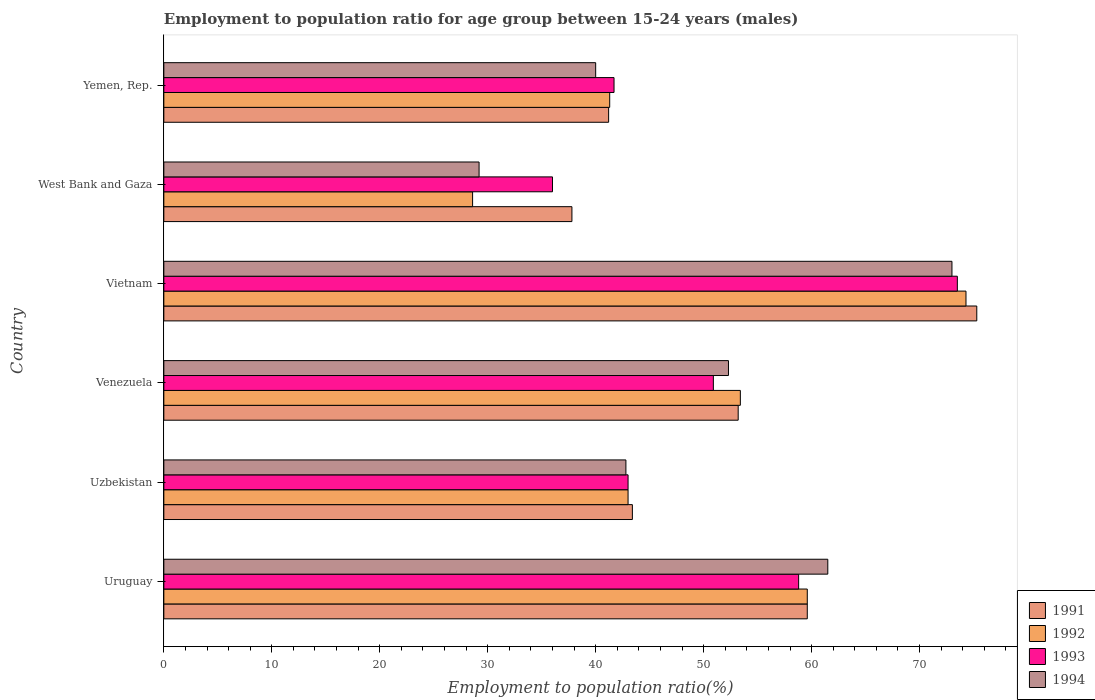How many bars are there on the 2nd tick from the top?
Your answer should be very brief. 4. What is the label of the 5th group of bars from the top?
Offer a very short reply. Uzbekistan. In how many cases, is the number of bars for a given country not equal to the number of legend labels?
Ensure brevity in your answer.  0. What is the employment to population ratio in 1993 in Uruguay?
Offer a very short reply. 58.8. Across all countries, what is the maximum employment to population ratio in 1991?
Ensure brevity in your answer.  75.3. Across all countries, what is the minimum employment to population ratio in 1994?
Give a very brief answer. 29.2. In which country was the employment to population ratio in 1992 maximum?
Provide a succinct answer. Vietnam. In which country was the employment to population ratio in 1994 minimum?
Make the answer very short. West Bank and Gaza. What is the total employment to population ratio in 1994 in the graph?
Make the answer very short. 298.8. What is the difference between the employment to population ratio in 1992 in Uruguay and that in Uzbekistan?
Your answer should be compact. 16.6. What is the difference between the employment to population ratio in 1993 in Venezuela and the employment to population ratio in 1994 in Uruguay?
Give a very brief answer. -10.6. What is the average employment to population ratio in 1994 per country?
Your answer should be compact. 49.8. What is the difference between the employment to population ratio in 1993 and employment to population ratio in 1991 in Uzbekistan?
Give a very brief answer. -0.4. What is the ratio of the employment to population ratio in 1993 in Uruguay to that in Venezuela?
Provide a short and direct response. 1.16. Is the employment to population ratio in 1991 in Uruguay less than that in Venezuela?
Offer a very short reply. No. Is the difference between the employment to population ratio in 1993 in Uruguay and West Bank and Gaza greater than the difference between the employment to population ratio in 1991 in Uruguay and West Bank and Gaza?
Offer a terse response. Yes. What is the difference between the highest and the second highest employment to population ratio in 1993?
Ensure brevity in your answer.  14.7. What is the difference between the highest and the lowest employment to population ratio in 1994?
Make the answer very short. 43.8. Is it the case that in every country, the sum of the employment to population ratio in 1993 and employment to population ratio in 1992 is greater than the sum of employment to population ratio in 1991 and employment to population ratio in 1994?
Offer a very short reply. No. What does the 1st bar from the bottom in Vietnam represents?
Provide a succinct answer. 1991. Are all the bars in the graph horizontal?
Offer a very short reply. Yes. What is the difference between two consecutive major ticks on the X-axis?
Provide a succinct answer. 10. How are the legend labels stacked?
Provide a short and direct response. Vertical. What is the title of the graph?
Provide a short and direct response. Employment to population ratio for age group between 15-24 years (males). Does "1985" appear as one of the legend labels in the graph?
Provide a succinct answer. No. What is the label or title of the X-axis?
Give a very brief answer. Employment to population ratio(%). What is the label or title of the Y-axis?
Provide a succinct answer. Country. What is the Employment to population ratio(%) of 1991 in Uruguay?
Provide a short and direct response. 59.6. What is the Employment to population ratio(%) of 1992 in Uruguay?
Ensure brevity in your answer.  59.6. What is the Employment to population ratio(%) of 1993 in Uruguay?
Offer a terse response. 58.8. What is the Employment to population ratio(%) in 1994 in Uruguay?
Offer a terse response. 61.5. What is the Employment to population ratio(%) in 1991 in Uzbekistan?
Offer a very short reply. 43.4. What is the Employment to population ratio(%) in 1993 in Uzbekistan?
Offer a very short reply. 43. What is the Employment to population ratio(%) of 1994 in Uzbekistan?
Your answer should be compact. 42.8. What is the Employment to population ratio(%) in 1991 in Venezuela?
Provide a short and direct response. 53.2. What is the Employment to population ratio(%) in 1992 in Venezuela?
Your answer should be compact. 53.4. What is the Employment to population ratio(%) in 1993 in Venezuela?
Your answer should be very brief. 50.9. What is the Employment to population ratio(%) of 1994 in Venezuela?
Your answer should be very brief. 52.3. What is the Employment to population ratio(%) in 1991 in Vietnam?
Your response must be concise. 75.3. What is the Employment to population ratio(%) of 1992 in Vietnam?
Your answer should be compact. 74.3. What is the Employment to population ratio(%) of 1993 in Vietnam?
Offer a very short reply. 73.5. What is the Employment to population ratio(%) in 1994 in Vietnam?
Keep it short and to the point. 73. What is the Employment to population ratio(%) of 1991 in West Bank and Gaza?
Your answer should be compact. 37.8. What is the Employment to population ratio(%) of 1992 in West Bank and Gaza?
Your answer should be very brief. 28.6. What is the Employment to population ratio(%) of 1993 in West Bank and Gaza?
Offer a terse response. 36. What is the Employment to population ratio(%) in 1994 in West Bank and Gaza?
Offer a very short reply. 29.2. What is the Employment to population ratio(%) in 1991 in Yemen, Rep.?
Your answer should be very brief. 41.2. What is the Employment to population ratio(%) in 1992 in Yemen, Rep.?
Your answer should be compact. 41.3. What is the Employment to population ratio(%) in 1993 in Yemen, Rep.?
Provide a succinct answer. 41.7. Across all countries, what is the maximum Employment to population ratio(%) of 1991?
Your response must be concise. 75.3. Across all countries, what is the maximum Employment to population ratio(%) of 1992?
Make the answer very short. 74.3. Across all countries, what is the maximum Employment to population ratio(%) of 1993?
Your answer should be very brief. 73.5. Across all countries, what is the maximum Employment to population ratio(%) of 1994?
Make the answer very short. 73. Across all countries, what is the minimum Employment to population ratio(%) of 1991?
Your answer should be very brief. 37.8. Across all countries, what is the minimum Employment to population ratio(%) of 1992?
Your answer should be compact. 28.6. Across all countries, what is the minimum Employment to population ratio(%) of 1994?
Provide a short and direct response. 29.2. What is the total Employment to population ratio(%) of 1991 in the graph?
Give a very brief answer. 310.5. What is the total Employment to population ratio(%) in 1992 in the graph?
Make the answer very short. 300.2. What is the total Employment to population ratio(%) of 1993 in the graph?
Provide a succinct answer. 303.9. What is the total Employment to population ratio(%) in 1994 in the graph?
Your answer should be compact. 298.8. What is the difference between the Employment to population ratio(%) of 1991 in Uruguay and that in Uzbekistan?
Ensure brevity in your answer.  16.2. What is the difference between the Employment to population ratio(%) in 1993 in Uruguay and that in Uzbekistan?
Offer a very short reply. 15.8. What is the difference between the Employment to population ratio(%) of 1994 in Uruguay and that in Uzbekistan?
Provide a succinct answer. 18.7. What is the difference between the Employment to population ratio(%) of 1991 in Uruguay and that in Venezuela?
Provide a succinct answer. 6.4. What is the difference between the Employment to population ratio(%) in 1992 in Uruguay and that in Venezuela?
Give a very brief answer. 6.2. What is the difference between the Employment to population ratio(%) in 1994 in Uruguay and that in Venezuela?
Provide a succinct answer. 9.2. What is the difference between the Employment to population ratio(%) of 1991 in Uruguay and that in Vietnam?
Give a very brief answer. -15.7. What is the difference between the Employment to population ratio(%) in 1992 in Uruguay and that in Vietnam?
Give a very brief answer. -14.7. What is the difference between the Employment to population ratio(%) in 1993 in Uruguay and that in Vietnam?
Your answer should be compact. -14.7. What is the difference between the Employment to population ratio(%) of 1994 in Uruguay and that in Vietnam?
Make the answer very short. -11.5. What is the difference between the Employment to population ratio(%) in 1991 in Uruguay and that in West Bank and Gaza?
Provide a short and direct response. 21.8. What is the difference between the Employment to population ratio(%) of 1992 in Uruguay and that in West Bank and Gaza?
Offer a very short reply. 31. What is the difference between the Employment to population ratio(%) in 1993 in Uruguay and that in West Bank and Gaza?
Provide a short and direct response. 22.8. What is the difference between the Employment to population ratio(%) of 1994 in Uruguay and that in West Bank and Gaza?
Your response must be concise. 32.3. What is the difference between the Employment to population ratio(%) in 1993 in Uruguay and that in Yemen, Rep.?
Offer a terse response. 17.1. What is the difference between the Employment to population ratio(%) of 1991 in Uzbekistan and that in Venezuela?
Provide a succinct answer. -9.8. What is the difference between the Employment to population ratio(%) in 1992 in Uzbekistan and that in Venezuela?
Give a very brief answer. -10.4. What is the difference between the Employment to population ratio(%) of 1991 in Uzbekistan and that in Vietnam?
Offer a terse response. -31.9. What is the difference between the Employment to population ratio(%) in 1992 in Uzbekistan and that in Vietnam?
Give a very brief answer. -31.3. What is the difference between the Employment to population ratio(%) in 1993 in Uzbekistan and that in Vietnam?
Your answer should be compact. -30.5. What is the difference between the Employment to population ratio(%) of 1994 in Uzbekistan and that in Vietnam?
Your response must be concise. -30.2. What is the difference between the Employment to population ratio(%) of 1991 in Uzbekistan and that in West Bank and Gaza?
Keep it short and to the point. 5.6. What is the difference between the Employment to population ratio(%) in 1992 in Uzbekistan and that in West Bank and Gaza?
Provide a succinct answer. 14.4. What is the difference between the Employment to population ratio(%) of 1993 in Uzbekistan and that in West Bank and Gaza?
Your answer should be compact. 7. What is the difference between the Employment to population ratio(%) in 1992 in Uzbekistan and that in Yemen, Rep.?
Your answer should be compact. 1.7. What is the difference between the Employment to population ratio(%) of 1991 in Venezuela and that in Vietnam?
Offer a terse response. -22.1. What is the difference between the Employment to population ratio(%) of 1992 in Venezuela and that in Vietnam?
Provide a short and direct response. -20.9. What is the difference between the Employment to population ratio(%) of 1993 in Venezuela and that in Vietnam?
Offer a very short reply. -22.6. What is the difference between the Employment to population ratio(%) in 1994 in Venezuela and that in Vietnam?
Keep it short and to the point. -20.7. What is the difference between the Employment to population ratio(%) of 1992 in Venezuela and that in West Bank and Gaza?
Your answer should be very brief. 24.8. What is the difference between the Employment to population ratio(%) in 1993 in Venezuela and that in West Bank and Gaza?
Provide a short and direct response. 14.9. What is the difference between the Employment to population ratio(%) in 1994 in Venezuela and that in West Bank and Gaza?
Keep it short and to the point. 23.1. What is the difference between the Employment to population ratio(%) of 1994 in Venezuela and that in Yemen, Rep.?
Offer a very short reply. 12.3. What is the difference between the Employment to population ratio(%) of 1991 in Vietnam and that in West Bank and Gaza?
Keep it short and to the point. 37.5. What is the difference between the Employment to population ratio(%) of 1992 in Vietnam and that in West Bank and Gaza?
Offer a terse response. 45.7. What is the difference between the Employment to population ratio(%) in 1993 in Vietnam and that in West Bank and Gaza?
Your answer should be very brief. 37.5. What is the difference between the Employment to population ratio(%) of 1994 in Vietnam and that in West Bank and Gaza?
Give a very brief answer. 43.8. What is the difference between the Employment to population ratio(%) in 1991 in Vietnam and that in Yemen, Rep.?
Make the answer very short. 34.1. What is the difference between the Employment to population ratio(%) of 1992 in Vietnam and that in Yemen, Rep.?
Make the answer very short. 33. What is the difference between the Employment to population ratio(%) in 1993 in Vietnam and that in Yemen, Rep.?
Keep it short and to the point. 31.8. What is the difference between the Employment to population ratio(%) of 1994 in Vietnam and that in Yemen, Rep.?
Provide a short and direct response. 33. What is the difference between the Employment to population ratio(%) of 1992 in West Bank and Gaza and that in Yemen, Rep.?
Make the answer very short. -12.7. What is the difference between the Employment to population ratio(%) of 1993 in West Bank and Gaza and that in Yemen, Rep.?
Your response must be concise. -5.7. What is the difference between the Employment to population ratio(%) in 1994 in West Bank and Gaza and that in Yemen, Rep.?
Your answer should be compact. -10.8. What is the difference between the Employment to population ratio(%) in 1991 in Uruguay and the Employment to population ratio(%) in 1992 in Uzbekistan?
Provide a short and direct response. 16.6. What is the difference between the Employment to population ratio(%) in 1991 in Uruguay and the Employment to population ratio(%) in 1993 in Uzbekistan?
Ensure brevity in your answer.  16.6. What is the difference between the Employment to population ratio(%) in 1991 in Uruguay and the Employment to population ratio(%) in 1994 in Uzbekistan?
Provide a succinct answer. 16.8. What is the difference between the Employment to population ratio(%) of 1993 in Uruguay and the Employment to population ratio(%) of 1994 in Uzbekistan?
Your answer should be very brief. 16. What is the difference between the Employment to population ratio(%) in 1991 in Uruguay and the Employment to population ratio(%) in 1992 in Venezuela?
Keep it short and to the point. 6.2. What is the difference between the Employment to population ratio(%) of 1991 in Uruguay and the Employment to population ratio(%) of 1993 in Venezuela?
Keep it short and to the point. 8.7. What is the difference between the Employment to population ratio(%) in 1991 in Uruguay and the Employment to population ratio(%) in 1994 in Venezuela?
Keep it short and to the point. 7.3. What is the difference between the Employment to population ratio(%) of 1991 in Uruguay and the Employment to population ratio(%) of 1992 in Vietnam?
Your answer should be very brief. -14.7. What is the difference between the Employment to population ratio(%) in 1991 in Uruguay and the Employment to population ratio(%) in 1993 in Vietnam?
Your answer should be compact. -13.9. What is the difference between the Employment to population ratio(%) in 1992 in Uruguay and the Employment to population ratio(%) in 1994 in Vietnam?
Ensure brevity in your answer.  -13.4. What is the difference between the Employment to population ratio(%) in 1991 in Uruguay and the Employment to population ratio(%) in 1992 in West Bank and Gaza?
Your response must be concise. 31. What is the difference between the Employment to population ratio(%) in 1991 in Uruguay and the Employment to population ratio(%) in 1993 in West Bank and Gaza?
Offer a very short reply. 23.6. What is the difference between the Employment to population ratio(%) in 1991 in Uruguay and the Employment to population ratio(%) in 1994 in West Bank and Gaza?
Provide a succinct answer. 30.4. What is the difference between the Employment to population ratio(%) in 1992 in Uruguay and the Employment to population ratio(%) in 1993 in West Bank and Gaza?
Provide a short and direct response. 23.6. What is the difference between the Employment to population ratio(%) in 1992 in Uruguay and the Employment to population ratio(%) in 1994 in West Bank and Gaza?
Offer a terse response. 30.4. What is the difference between the Employment to population ratio(%) in 1993 in Uruguay and the Employment to population ratio(%) in 1994 in West Bank and Gaza?
Your response must be concise. 29.6. What is the difference between the Employment to population ratio(%) in 1991 in Uruguay and the Employment to population ratio(%) in 1993 in Yemen, Rep.?
Provide a short and direct response. 17.9. What is the difference between the Employment to population ratio(%) in 1991 in Uruguay and the Employment to population ratio(%) in 1994 in Yemen, Rep.?
Give a very brief answer. 19.6. What is the difference between the Employment to population ratio(%) of 1992 in Uruguay and the Employment to population ratio(%) of 1993 in Yemen, Rep.?
Give a very brief answer. 17.9. What is the difference between the Employment to population ratio(%) of 1992 in Uruguay and the Employment to population ratio(%) of 1994 in Yemen, Rep.?
Your answer should be very brief. 19.6. What is the difference between the Employment to population ratio(%) of 1992 in Uzbekistan and the Employment to population ratio(%) of 1993 in Venezuela?
Keep it short and to the point. -7.9. What is the difference between the Employment to population ratio(%) in 1991 in Uzbekistan and the Employment to population ratio(%) in 1992 in Vietnam?
Your answer should be compact. -30.9. What is the difference between the Employment to population ratio(%) of 1991 in Uzbekistan and the Employment to population ratio(%) of 1993 in Vietnam?
Your answer should be compact. -30.1. What is the difference between the Employment to population ratio(%) in 1991 in Uzbekistan and the Employment to population ratio(%) in 1994 in Vietnam?
Provide a succinct answer. -29.6. What is the difference between the Employment to population ratio(%) of 1992 in Uzbekistan and the Employment to population ratio(%) of 1993 in Vietnam?
Ensure brevity in your answer.  -30.5. What is the difference between the Employment to population ratio(%) of 1993 in Uzbekistan and the Employment to population ratio(%) of 1994 in Vietnam?
Your answer should be compact. -30. What is the difference between the Employment to population ratio(%) of 1991 in Uzbekistan and the Employment to population ratio(%) of 1992 in West Bank and Gaza?
Your answer should be compact. 14.8. What is the difference between the Employment to population ratio(%) in 1992 in Uzbekistan and the Employment to population ratio(%) in 1993 in West Bank and Gaza?
Make the answer very short. 7. What is the difference between the Employment to population ratio(%) of 1991 in Uzbekistan and the Employment to population ratio(%) of 1993 in Yemen, Rep.?
Your answer should be compact. 1.7. What is the difference between the Employment to population ratio(%) of 1992 in Uzbekistan and the Employment to population ratio(%) of 1993 in Yemen, Rep.?
Keep it short and to the point. 1.3. What is the difference between the Employment to population ratio(%) of 1992 in Uzbekistan and the Employment to population ratio(%) of 1994 in Yemen, Rep.?
Ensure brevity in your answer.  3. What is the difference between the Employment to population ratio(%) of 1991 in Venezuela and the Employment to population ratio(%) of 1992 in Vietnam?
Give a very brief answer. -21.1. What is the difference between the Employment to population ratio(%) of 1991 in Venezuela and the Employment to population ratio(%) of 1993 in Vietnam?
Your answer should be compact. -20.3. What is the difference between the Employment to population ratio(%) of 1991 in Venezuela and the Employment to population ratio(%) of 1994 in Vietnam?
Your response must be concise. -19.8. What is the difference between the Employment to population ratio(%) of 1992 in Venezuela and the Employment to population ratio(%) of 1993 in Vietnam?
Your answer should be very brief. -20.1. What is the difference between the Employment to population ratio(%) of 1992 in Venezuela and the Employment to population ratio(%) of 1994 in Vietnam?
Offer a very short reply. -19.6. What is the difference between the Employment to population ratio(%) of 1993 in Venezuela and the Employment to population ratio(%) of 1994 in Vietnam?
Ensure brevity in your answer.  -22.1. What is the difference between the Employment to population ratio(%) of 1991 in Venezuela and the Employment to population ratio(%) of 1992 in West Bank and Gaza?
Your response must be concise. 24.6. What is the difference between the Employment to population ratio(%) in 1992 in Venezuela and the Employment to population ratio(%) in 1993 in West Bank and Gaza?
Your response must be concise. 17.4. What is the difference between the Employment to population ratio(%) of 1992 in Venezuela and the Employment to population ratio(%) of 1994 in West Bank and Gaza?
Provide a succinct answer. 24.2. What is the difference between the Employment to population ratio(%) of 1993 in Venezuela and the Employment to population ratio(%) of 1994 in West Bank and Gaza?
Offer a terse response. 21.7. What is the difference between the Employment to population ratio(%) of 1991 in Venezuela and the Employment to population ratio(%) of 1994 in Yemen, Rep.?
Your answer should be compact. 13.2. What is the difference between the Employment to population ratio(%) of 1992 in Venezuela and the Employment to population ratio(%) of 1993 in Yemen, Rep.?
Offer a very short reply. 11.7. What is the difference between the Employment to population ratio(%) of 1992 in Venezuela and the Employment to population ratio(%) of 1994 in Yemen, Rep.?
Offer a terse response. 13.4. What is the difference between the Employment to population ratio(%) in 1991 in Vietnam and the Employment to population ratio(%) in 1992 in West Bank and Gaza?
Your response must be concise. 46.7. What is the difference between the Employment to population ratio(%) of 1991 in Vietnam and the Employment to population ratio(%) of 1993 in West Bank and Gaza?
Ensure brevity in your answer.  39.3. What is the difference between the Employment to population ratio(%) in 1991 in Vietnam and the Employment to population ratio(%) in 1994 in West Bank and Gaza?
Your answer should be compact. 46.1. What is the difference between the Employment to population ratio(%) in 1992 in Vietnam and the Employment to population ratio(%) in 1993 in West Bank and Gaza?
Offer a very short reply. 38.3. What is the difference between the Employment to population ratio(%) of 1992 in Vietnam and the Employment to population ratio(%) of 1994 in West Bank and Gaza?
Provide a succinct answer. 45.1. What is the difference between the Employment to population ratio(%) of 1993 in Vietnam and the Employment to population ratio(%) of 1994 in West Bank and Gaza?
Provide a succinct answer. 44.3. What is the difference between the Employment to population ratio(%) of 1991 in Vietnam and the Employment to population ratio(%) of 1993 in Yemen, Rep.?
Make the answer very short. 33.6. What is the difference between the Employment to population ratio(%) of 1991 in Vietnam and the Employment to population ratio(%) of 1994 in Yemen, Rep.?
Give a very brief answer. 35.3. What is the difference between the Employment to population ratio(%) in 1992 in Vietnam and the Employment to population ratio(%) in 1993 in Yemen, Rep.?
Offer a terse response. 32.6. What is the difference between the Employment to population ratio(%) of 1992 in Vietnam and the Employment to population ratio(%) of 1994 in Yemen, Rep.?
Your answer should be compact. 34.3. What is the difference between the Employment to population ratio(%) in 1993 in Vietnam and the Employment to population ratio(%) in 1994 in Yemen, Rep.?
Keep it short and to the point. 33.5. What is the difference between the Employment to population ratio(%) in 1991 in West Bank and Gaza and the Employment to population ratio(%) in 1994 in Yemen, Rep.?
Your answer should be compact. -2.2. What is the difference between the Employment to population ratio(%) of 1992 in West Bank and Gaza and the Employment to population ratio(%) of 1994 in Yemen, Rep.?
Your answer should be very brief. -11.4. What is the difference between the Employment to population ratio(%) in 1993 in West Bank and Gaza and the Employment to population ratio(%) in 1994 in Yemen, Rep.?
Offer a terse response. -4. What is the average Employment to population ratio(%) of 1991 per country?
Your answer should be compact. 51.75. What is the average Employment to population ratio(%) in 1992 per country?
Ensure brevity in your answer.  50.03. What is the average Employment to population ratio(%) of 1993 per country?
Keep it short and to the point. 50.65. What is the average Employment to population ratio(%) of 1994 per country?
Provide a succinct answer. 49.8. What is the difference between the Employment to population ratio(%) of 1991 and Employment to population ratio(%) of 1992 in Uruguay?
Your answer should be compact. 0. What is the difference between the Employment to population ratio(%) in 1992 and Employment to population ratio(%) in 1994 in Uruguay?
Offer a very short reply. -1.9. What is the difference between the Employment to population ratio(%) of 1991 and Employment to population ratio(%) of 1992 in Uzbekistan?
Ensure brevity in your answer.  0.4. What is the difference between the Employment to population ratio(%) in 1991 and Employment to population ratio(%) in 1993 in Uzbekistan?
Offer a terse response. 0.4. What is the difference between the Employment to population ratio(%) in 1992 and Employment to population ratio(%) in 1994 in Uzbekistan?
Provide a succinct answer. 0.2. What is the difference between the Employment to population ratio(%) in 1993 and Employment to population ratio(%) in 1994 in Uzbekistan?
Your answer should be very brief. 0.2. What is the difference between the Employment to population ratio(%) of 1991 and Employment to population ratio(%) of 1992 in Venezuela?
Your answer should be compact. -0.2. What is the difference between the Employment to population ratio(%) in 1991 and Employment to population ratio(%) in 1994 in Venezuela?
Make the answer very short. 0.9. What is the difference between the Employment to population ratio(%) of 1992 and Employment to population ratio(%) of 1993 in Venezuela?
Offer a terse response. 2.5. What is the difference between the Employment to population ratio(%) of 1991 and Employment to population ratio(%) of 1992 in Vietnam?
Ensure brevity in your answer.  1. What is the difference between the Employment to population ratio(%) of 1991 and Employment to population ratio(%) of 1994 in Vietnam?
Your answer should be very brief. 2.3. What is the difference between the Employment to population ratio(%) of 1991 and Employment to population ratio(%) of 1993 in West Bank and Gaza?
Offer a very short reply. 1.8. What is the difference between the Employment to population ratio(%) in 1991 and Employment to population ratio(%) in 1994 in West Bank and Gaza?
Offer a very short reply. 8.6. What is the difference between the Employment to population ratio(%) of 1991 and Employment to population ratio(%) of 1992 in Yemen, Rep.?
Keep it short and to the point. -0.1. What is the difference between the Employment to population ratio(%) in 1991 and Employment to population ratio(%) in 1993 in Yemen, Rep.?
Give a very brief answer. -0.5. What is the ratio of the Employment to population ratio(%) in 1991 in Uruguay to that in Uzbekistan?
Your answer should be compact. 1.37. What is the ratio of the Employment to population ratio(%) of 1992 in Uruguay to that in Uzbekistan?
Offer a very short reply. 1.39. What is the ratio of the Employment to population ratio(%) in 1993 in Uruguay to that in Uzbekistan?
Your answer should be compact. 1.37. What is the ratio of the Employment to population ratio(%) of 1994 in Uruguay to that in Uzbekistan?
Offer a terse response. 1.44. What is the ratio of the Employment to population ratio(%) of 1991 in Uruguay to that in Venezuela?
Provide a short and direct response. 1.12. What is the ratio of the Employment to population ratio(%) of 1992 in Uruguay to that in Venezuela?
Provide a short and direct response. 1.12. What is the ratio of the Employment to population ratio(%) of 1993 in Uruguay to that in Venezuela?
Offer a terse response. 1.16. What is the ratio of the Employment to population ratio(%) in 1994 in Uruguay to that in Venezuela?
Ensure brevity in your answer.  1.18. What is the ratio of the Employment to population ratio(%) of 1991 in Uruguay to that in Vietnam?
Your response must be concise. 0.79. What is the ratio of the Employment to population ratio(%) in 1992 in Uruguay to that in Vietnam?
Ensure brevity in your answer.  0.8. What is the ratio of the Employment to population ratio(%) of 1993 in Uruguay to that in Vietnam?
Your answer should be very brief. 0.8. What is the ratio of the Employment to population ratio(%) of 1994 in Uruguay to that in Vietnam?
Ensure brevity in your answer.  0.84. What is the ratio of the Employment to population ratio(%) in 1991 in Uruguay to that in West Bank and Gaza?
Your answer should be compact. 1.58. What is the ratio of the Employment to population ratio(%) of 1992 in Uruguay to that in West Bank and Gaza?
Offer a terse response. 2.08. What is the ratio of the Employment to population ratio(%) of 1993 in Uruguay to that in West Bank and Gaza?
Offer a terse response. 1.63. What is the ratio of the Employment to population ratio(%) in 1994 in Uruguay to that in West Bank and Gaza?
Ensure brevity in your answer.  2.11. What is the ratio of the Employment to population ratio(%) in 1991 in Uruguay to that in Yemen, Rep.?
Offer a very short reply. 1.45. What is the ratio of the Employment to population ratio(%) of 1992 in Uruguay to that in Yemen, Rep.?
Offer a very short reply. 1.44. What is the ratio of the Employment to population ratio(%) in 1993 in Uruguay to that in Yemen, Rep.?
Your answer should be compact. 1.41. What is the ratio of the Employment to population ratio(%) in 1994 in Uruguay to that in Yemen, Rep.?
Give a very brief answer. 1.54. What is the ratio of the Employment to population ratio(%) in 1991 in Uzbekistan to that in Venezuela?
Make the answer very short. 0.82. What is the ratio of the Employment to population ratio(%) of 1992 in Uzbekistan to that in Venezuela?
Your answer should be compact. 0.81. What is the ratio of the Employment to population ratio(%) in 1993 in Uzbekistan to that in Venezuela?
Provide a succinct answer. 0.84. What is the ratio of the Employment to population ratio(%) of 1994 in Uzbekistan to that in Venezuela?
Provide a short and direct response. 0.82. What is the ratio of the Employment to population ratio(%) in 1991 in Uzbekistan to that in Vietnam?
Make the answer very short. 0.58. What is the ratio of the Employment to population ratio(%) in 1992 in Uzbekistan to that in Vietnam?
Make the answer very short. 0.58. What is the ratio of the Employment to population ratio(%) in 1993 in Uzbekistan to that in Vietnam?
Make the answer very short. 0.58. What is the ratio of the Employment to population ratio(%) of 1994 in Uzbekistan to that in Vietnam?
Keep it short and to the point. 0.59. What is the ratio of the Employment to population ratio(%) of 1991 in Uzbekistan to that in West Bank and Gaza?
Ensure brevity in your answer.  1.15. What is the ratio of the Employment to population ratio(%) in 1992 in Uzbekistan to that in West Bank and Gaza?
Offer a very short reply. 1.5. What is the ratio of the Employment to population ratio(%) of 1993 in Uzbekistan to that in West Bank and Gaza?
Your answer should be very brief. 1.19. What is the ratio of the Employment to population ratio(%) in 1994 in Uzbekistan to that in West Bank and Gaza?
Your answer should be very brief. 1.47. What is the ratio of the Employment to population ratio(%) of 1991 in Uzbekistan to that in Yemen, Rep.?
Ensure brevity in your answer.  1.05. What is the ratio of the Employment to population ratio(%) of 1992 in Uzbekistan to that in Yemen, Rep.?
Keep it short and to the point. 1.04. What is the ratio of the Employment to population ratio(%) of 1993 in Uzbekistan to that in Yemen, Rep.?
Give a very brief answer. 1.03. What is the ratio of the Employment to population ratio(%) in 1994 in Uzbekistan to that in Yemen, Rep.?
Provide a succinct answer. 1.07. What is the ratio of the Employment to population ratio(%) of 1991 in Venezuela to that in Vietnam?
Provide a short and direct response. 0.71. What is the ratio of the Employment to population ratio(%) of 1992 in Venezuela to that in Vietnam?
Give a very brief answer. 0.72. What is the ratio of the Employment to population ratio(%) of 1993 in Venezuela to that in Vietnam?
Your answer should be very brief. 0.69. What is the ratio of the Employment to population ratio(%) in 1994 in Venezuela to that in Vietnam?
Offer a very short reply. 0.72. What is the ratio of the Employment to population ratio(%) in 1991 in Venezuela to that in West Bank and Gaza?
Provide a succinct answer. 1.41. What is the ratio of the Employment to population ratio(%) of 1992 in Venezuela to that in West Bank and Gaza?
Keep it short and to the point. 1.87. What is the ratio of the Employment to population ratio(%) in 1993 in Venezuela to that in West Bank and Gaza?
Your answer should be very brief. 1.41. What is the ratio of the Employment to population ratio(%) in 1994 in Venezuela to that in West Bank and Gaza?
Provide a succinct answer. 1.79. What is the ratio of the Employment to population ratio(%) of 1991 in Venezuela to that in Yemen, Rep.?
Your answer should be very brief. 1.29. What is the ratio of the Employment to population ratio(%) of 1992 in Venezuela to that in Yemen, Rep.?
Your response must be concise. 1.29. What is the ratio of the Employment to population ratio(%) of 1993 in Venezuela to that in Yemen, Rep.?
Give a very brief answer. 1.22. What is the ratio of the Employment to population ratio(%) of 1994 in Venezuela to that in Yemen, Rep.?
Offer a very short reply. 1.31. What is the ratio of the Employment to population ratio(%) in 1991 in Vietnam to that in West Bank and Gaza?
Make the answer very short. 1.99. What is the ratio of the Employment to population ratio(%) in 1992 in Vietnam to that in West Bank and Gaza?
Ensure brevity in your answer.  2.6. What is the ratio of the Employment to population ratio(%) of 1993 in Vietnam to that in West Bank and Gaza?
Make the answer very short. 2.04. What is the ratio of the Employment to population ratio(%) of 1994 in Vietnam to that in West Bank and Gaza?
Offer a very short reply. 2.5. What is the ratio of the Employment to population ratio(%) of 1991 in Vietnam to that in Yemen, Rep.?
Your response must be concise. 1.83. What is the ratio of the Employment to population ratio(%) in 1992 in Vietnam to that in Yemen, Rep.?
Your answer should be compact. 1.8. What is the ratio of the Employment to population ratio(%) of 1993 in Vietnam to that in Yemen, Rep.?
Your answer should be compact. 1.76. What is the ratio of the Employment to population ratio(%) in 1994 in Vietnam to that in Yemen, Rep.?
Keep it short and to the point. 1.82. What is the ratio of the Employment to population ratio(%) in 1991 in West Bank and Gaza to that in Yemen, Rep.?
Give a very brief answer. 0.92. What is the ratio of the Employment to population ratio(%) in 1992 in West Bank and Gaza to that in Yemen, Rep.?
Your answer should be very brief. 0.69. What is the ratio of the Employment to population ratio(%) in 1993 in West Bank and Gaza to that in Yemen, Rep.?
Your answer should be compact. 0.86. What is the ratio of the Employment to population ratio(%) in 1994 in West Bank and Gaza to that in Yemen, Rep.?
Your response must be concise. 0.73. What is the difference between the highest and the second highest Employment to population ratio(%) of 1992?
Give a very brief answer. 14.7. What is the difference between the highest and the second highest Employment to population ratio(%) in 1993?
Make the answer very short. 14.7. What is the difference between the highest and the lowest Employment to population ratio(%) in 1991?
Offer a very short reply. 37.5. What is the difference between the highest and the lowest Employment to population ratio(%) in 1992?
Your answer should be very brief. 45.7. What is the difference between the highest and the lowest Employment to population ratio(%) in 1993?
Your answer should be compact. 37.5. What is the difference between the highest and the lowest Employment to population ratio(%) in 1994?
Keep it short and to the point. 43.8. 